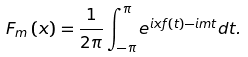<formula> <loc_0><loc_0><loc_500><loc_500>F _ { m } \left ( x \right ) = \frac { 1 } { 2 \pi } \int _ { - \pi } ^ { \pi } e ^ { i x f \left ( t \right ) - i m t } d t .</formula> 